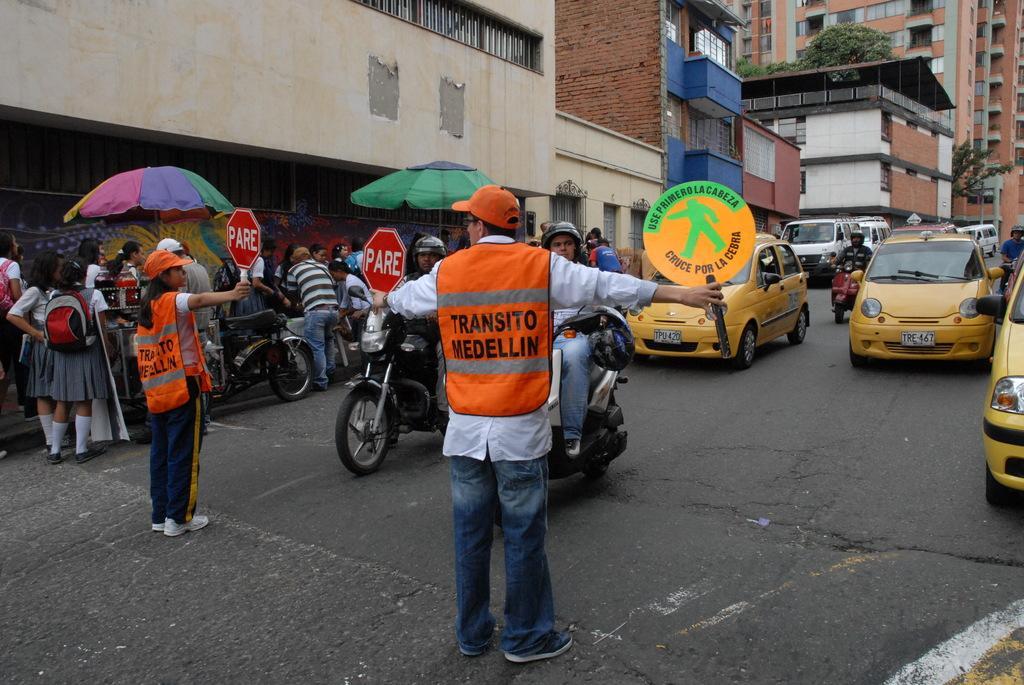Please provide a concise description of this image. This image is clicked on the road. There are vehicles moving on the road. In the foreground there are two people standing on the road. They are holding sign boards in their hands. To the left there is a walkway. There are people standing on the walkway. Behind the walkway there are buildings and trees. 